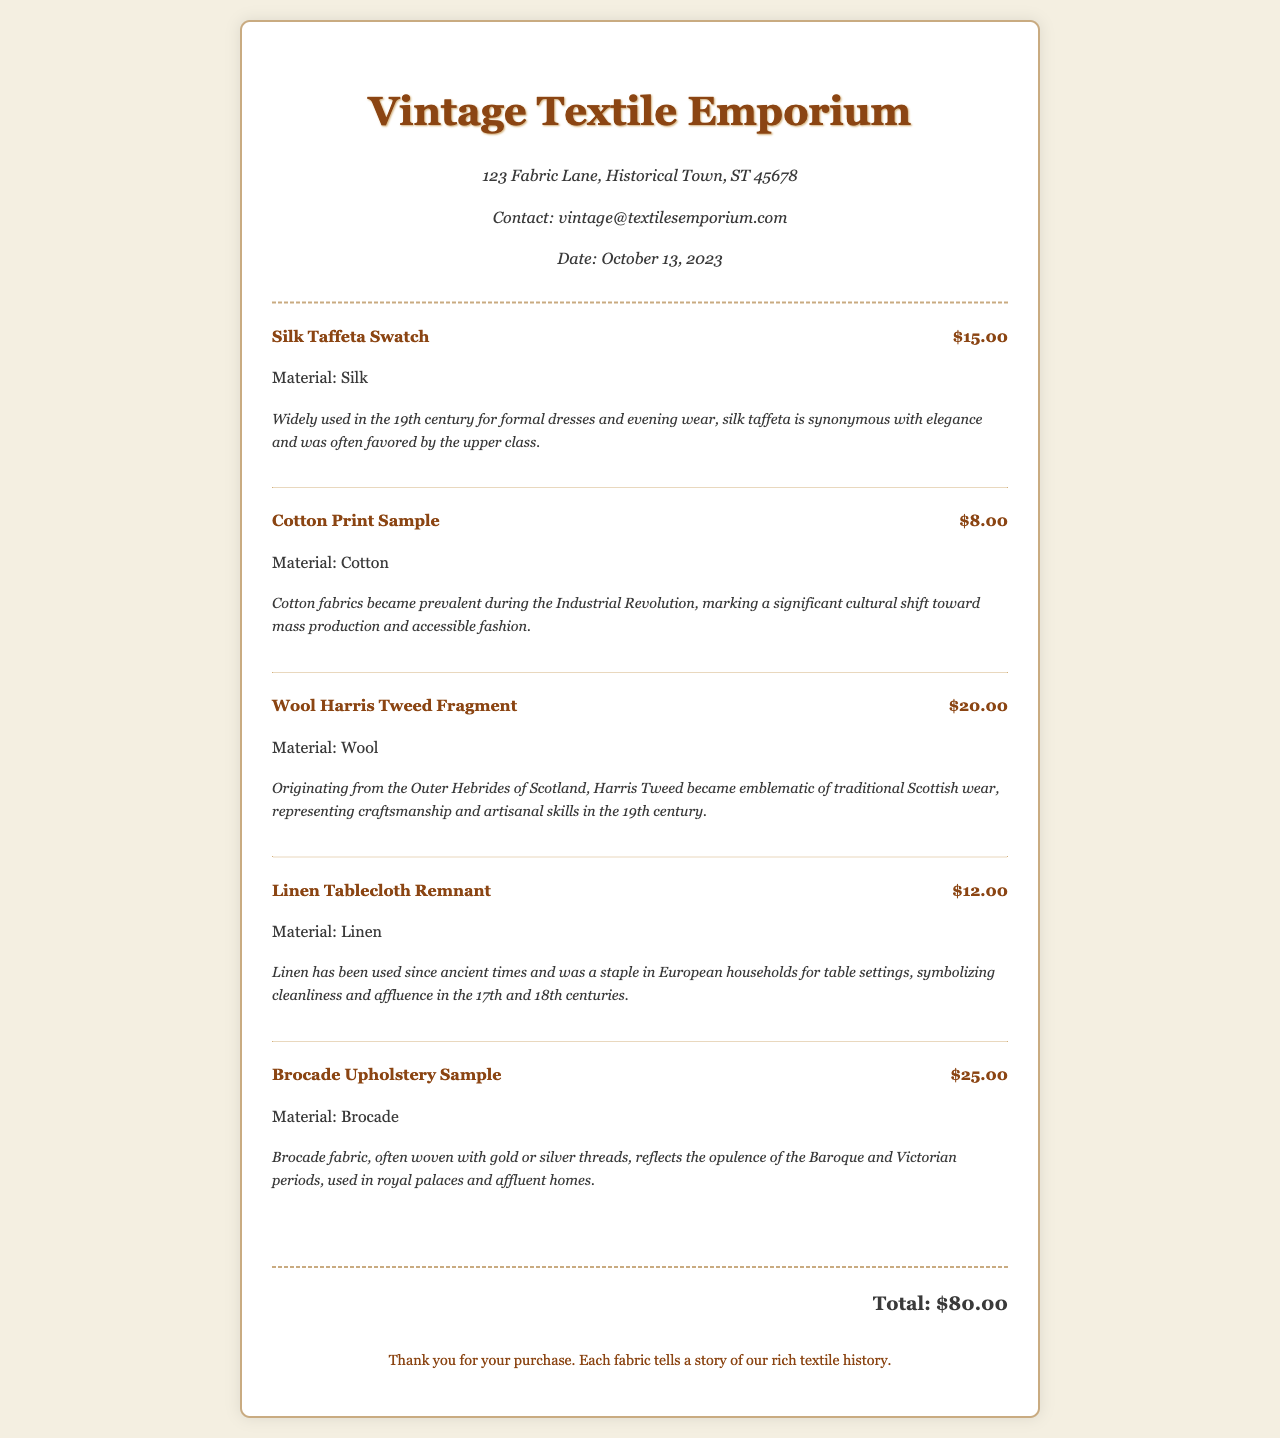what is the name of the vendor? The vendor's name is displayed at the top of the receipt, indicating where the purchase was made.
Answer: Vintage Textile Emporium what is the total amount spent? The total is provided at the bottom of the receipt, summarizing the costs of all items purchased.
Answer: $80.00 how many fabric swatches are listed? The number of fabric swatches corresponds to the items detailed in the receipt section under "items."
Answer: 5 what is the price of the Silk Taffeta Swatch? The price for this specific item is indicated next to its name in the itemized list.
Answer: $15.00 which material is associated with the Brocade Upholstery Sample? The material type for each item is stated directly below its price in the item description.
Answer: Brocade what historical significance is associated with Cotton Print Sample? The significance offers insight into the cultural shift regarding fabric usage during a specific historical period.
Answer: Cotton fabrics became prevalent during the Industrial Revolution, marking a significant cultural shift toward mass production and accessible fashion what is the email address of the vendor? The vendor's contact information is included in the vendor info section of the receipt.
Answer: vintage@textilesemporium.com what type of fabric is the Wool Harris Tweed Fragment made from? Each item lists its material directly under the title and price, allowing for easy identification.
Answer: Wool on which date was the purchase made? The purchase date is noted in the vendor information section of the receipt.
Answer: October 13, 2023 